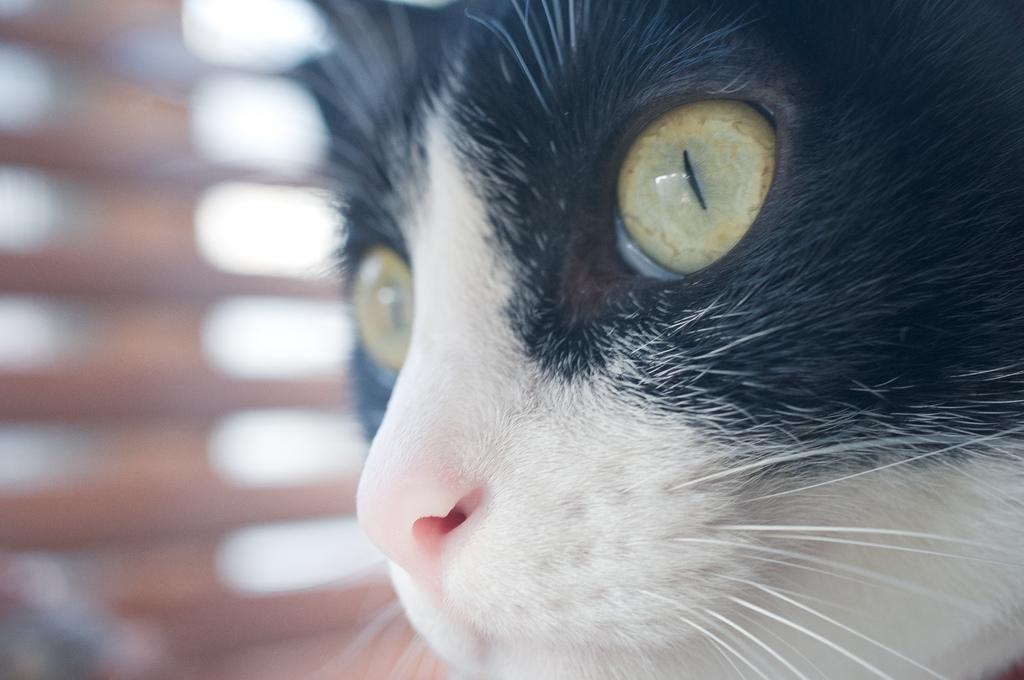What type of animal is present in the image? There is a cat in the image. What type of powder is being used by the secretary in the image? There is no secretary or powder present in the image; it only features a cat. 